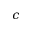<formula> <loc_0><loc_0><loc_500><loc_500>c</formula> 